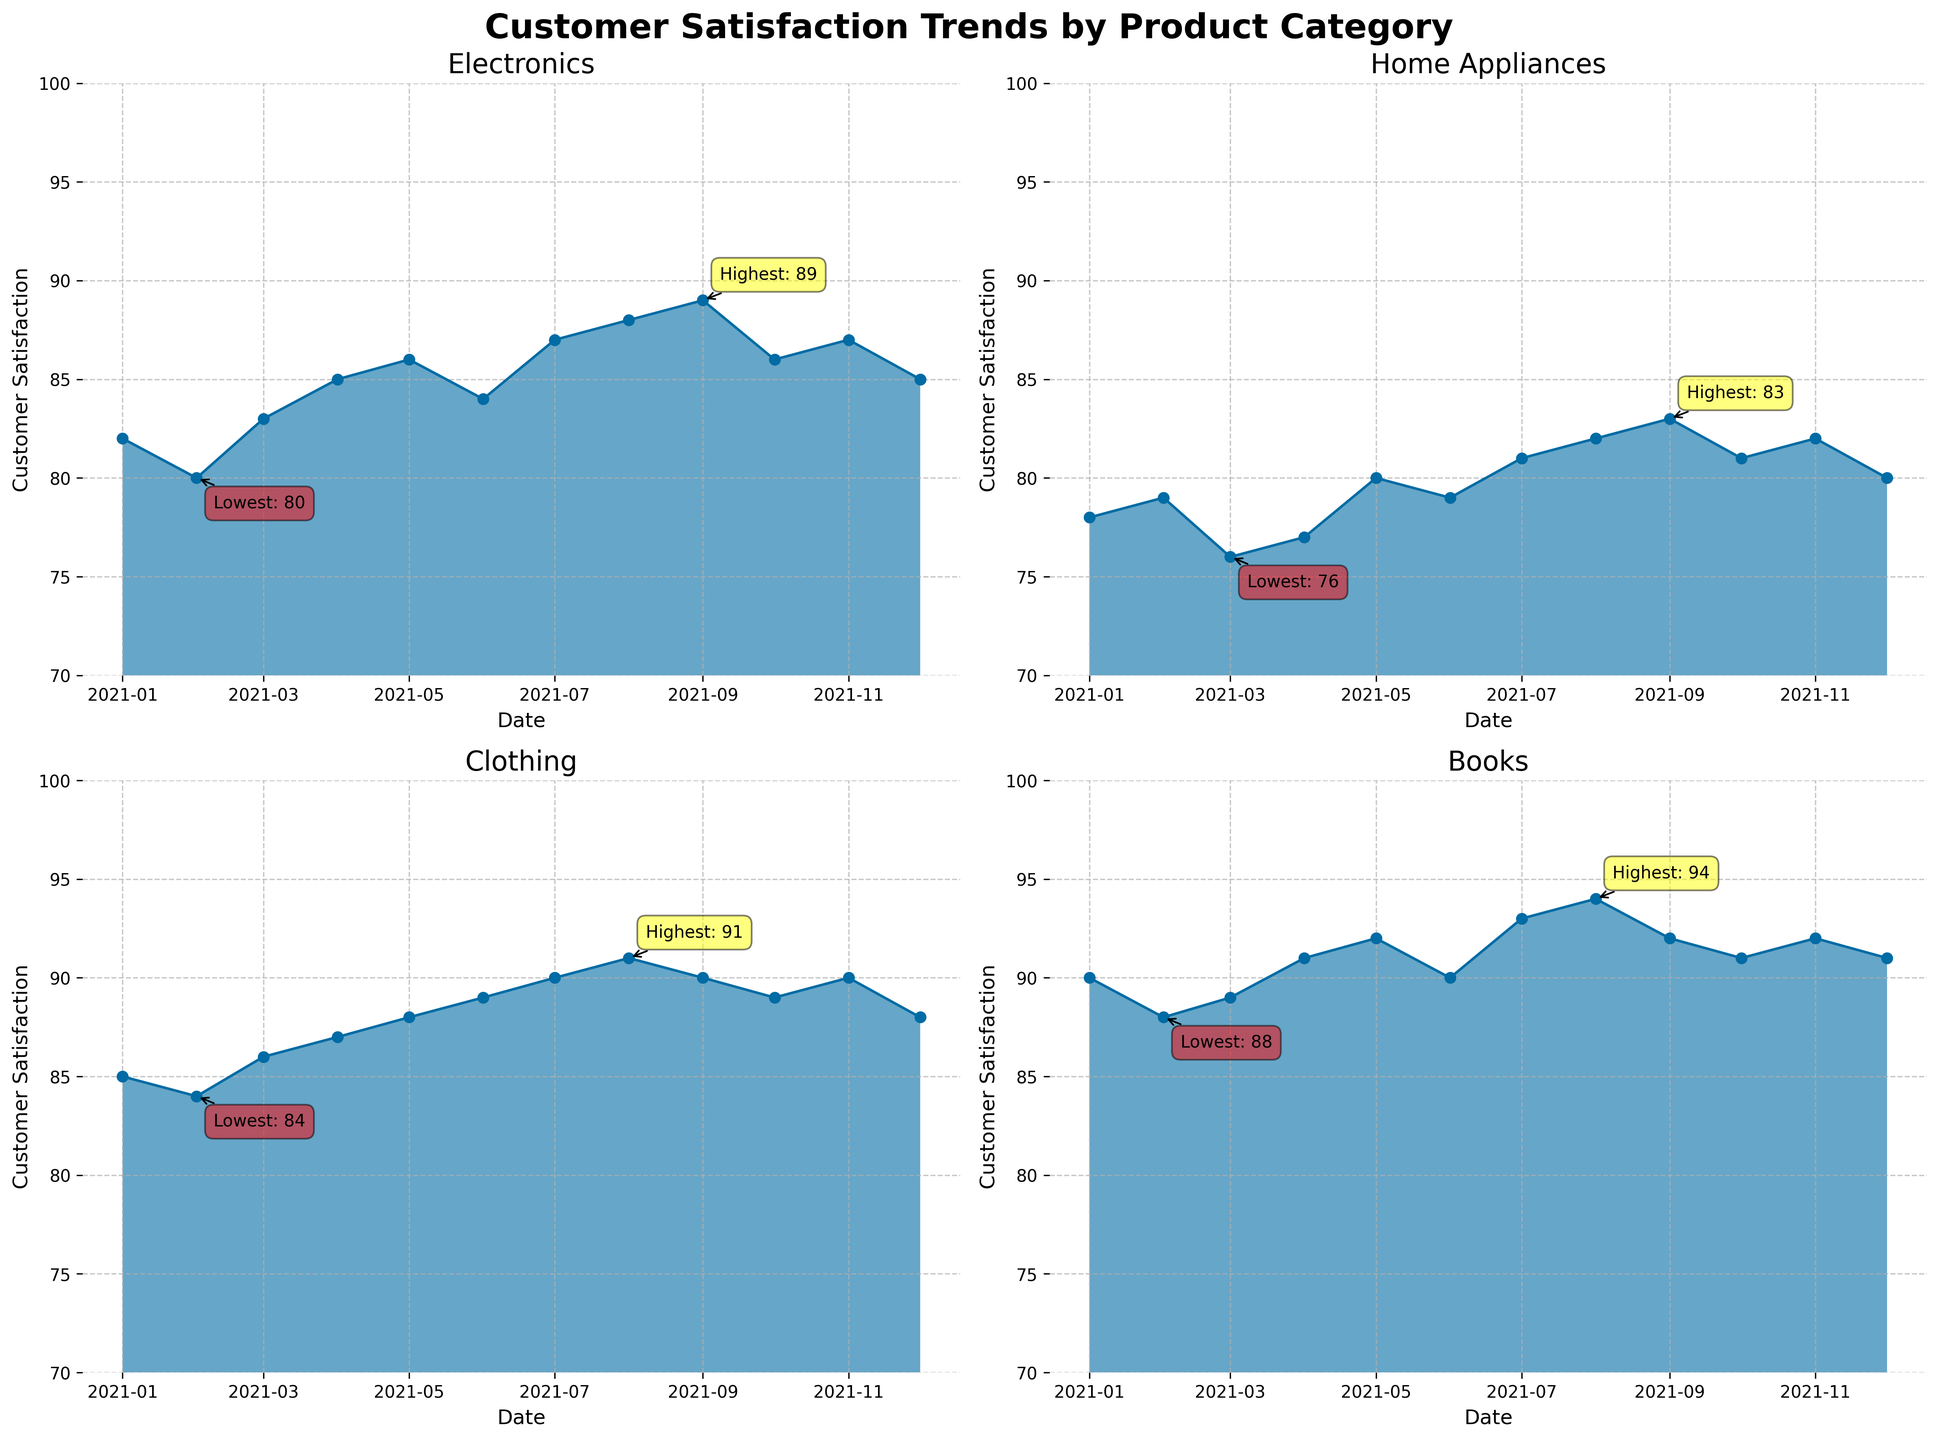What is the title of the overall figure? The title of the overall figure is usually placed at the top and is clearly visible as the main description of the entire plot. In this case, the title is "Customer Satisfaction Trends by Product Category".
Answer: Customer Satisfaction Trends by Product Category Which product category has the highest customer satisfaction in August 2021? To find the highest customer satisfaction in August 2021, look at the plot for August under each individual product category and compare the values. The Electronics category shows a satisfaction score of 88, Home Appliances shows 82, Clothing shows 91, and Books shows 94. The highest value is 94 in the Books category.
Answer: Books What month and category had the lowest customer satisfaction score? For the lowest customer satisfaction score, examine each subplot and check the lowest annotated values. The Home Appliances category in March 2021 has the lowest satisfaction score, which is 76.
Answer: March, Home Appliances Compare the trend of customer satisfaction between the Electronics and Home Appliances categories. Which one showed a consistent increase over the year? Examine the overall trend line for both Electronics and Home Appliances. Electronics starts at 82 in January and ends at 85 in December, exhibiting variations but generally increasing. Home Appliances starts at 78 in January and ends at 80 in December, also increasing but less consistently.
Answer: Electronics In which month did the Clothing category reach its highest satisfaction score, and what was the score? Check the highest point annotated in the Clothing subplot. The highest satisfaction score is in September 2021, and it is annotated as 91.
Answer: September, 91 What was the customer satisfaction for Books in May and how does it compare with Electronics in the same month? Check the plots for May under the Books and Electronics subplots. Books show a satisfaction score of 92 while Electronics shows 86. Comparing these two values, Books has a higher satisfaction score.
Answer: Books: 92, Electronics: 86 What are the values of the lowest customer satisfaction scores for Electronics and Books? Look for the lowest annotated points in both the Electronics and Books subplots. The lowest score for Electronics is 80 in February, and for Books, it is 88 in February.
Answer: Electronics: 80, Books: 88 Which category had the most significant increase in customer satisfaction from February to March? Compare the February and March values for each category. Electronics increased from 80 to 83, Home Appliances decreased from 79 to 76, Clothing increased from 84 to 86, and Books increased from 88 to 89. Electronics had the largest increase of 3 percentage points.
Answer: Electronics 